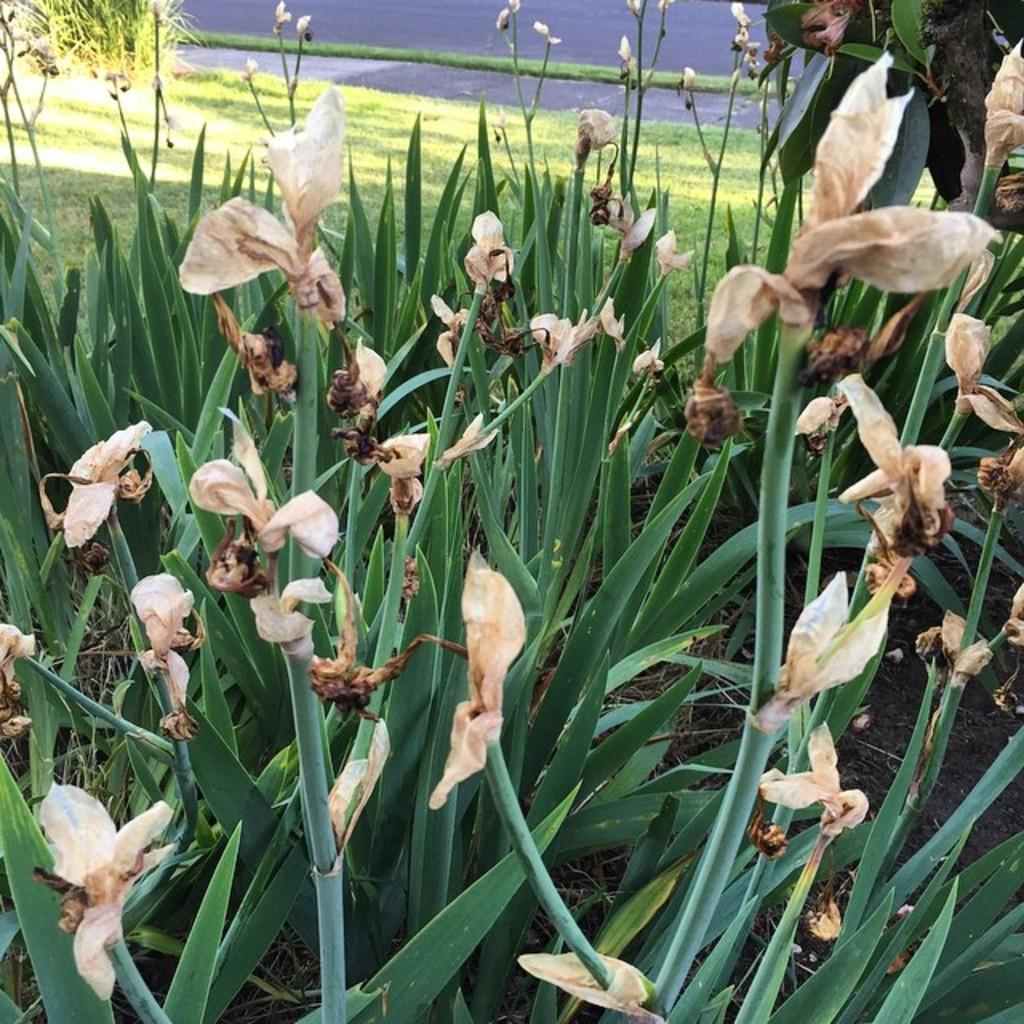What type of vegetation can be seen in the image? There are plants in the image. Are there any dried plants visible in the image? Yes, there are dry flowers in the image. What type of surface is visible in the image? The ground with grass is visible in the image. What type of man-made structure can be seen in the image? There is a road in the image. Can you tell me how many bikes are parked near the plants in the image? There is no bike present in the image; it only features plants, dry flowers, grassy ground, and a road. What type of wing is visible on the plants in the image? There are no wings present on the plants in the image. 